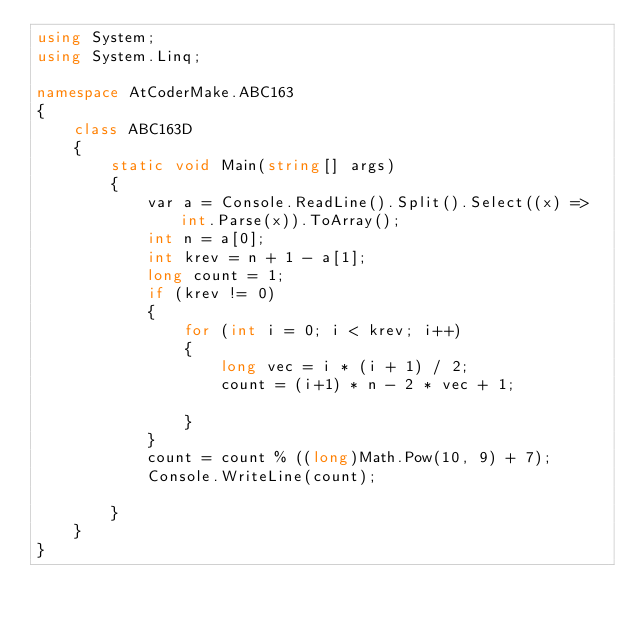Convert code to text. <code><loc_0><loc_0><loc_500><loc_500><_C#_>using System;
using System.Linq;

namespace AtCoderMake.ABC163
{
    class ABC163D
    {
        static void Main(string[] args)
        {
            var a = Console.ReadLine().Split().Select((x) => int.Parse(x)).ToArray();
            int n = a[0];
            int krev = n + 1 - a[1];
            long count = 1;
            if (krev != 0)
            {
                for (int i = 0; i < krev; i++)
                {
                    long vec = i * (i + 1) / 2;
                    count = (i+1) * n - 2 * vec + 1;
                    
                }
            }
            count = count % ((long)Math.Pow(10, 9) + 7);
            Console.WriteLine(count);

        }
    }
}
</code> 